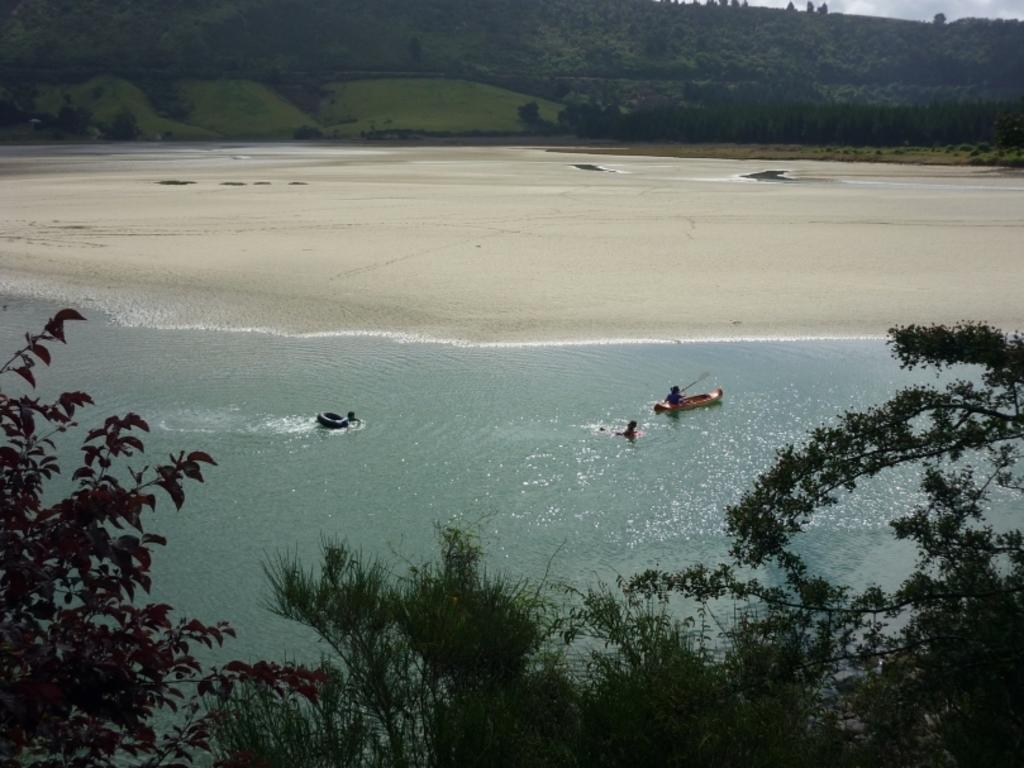In one or two sentences, can you explain what this image depicts? In this image I can see a boat and few people. I can see a water,trees and mountains. 